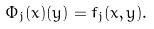<formula> <loc_0><loc_0><loc_500><loc_500>\Phi _ { j } ( x ) ( y ) = f _ { j } ( x , y ) .</formula> 